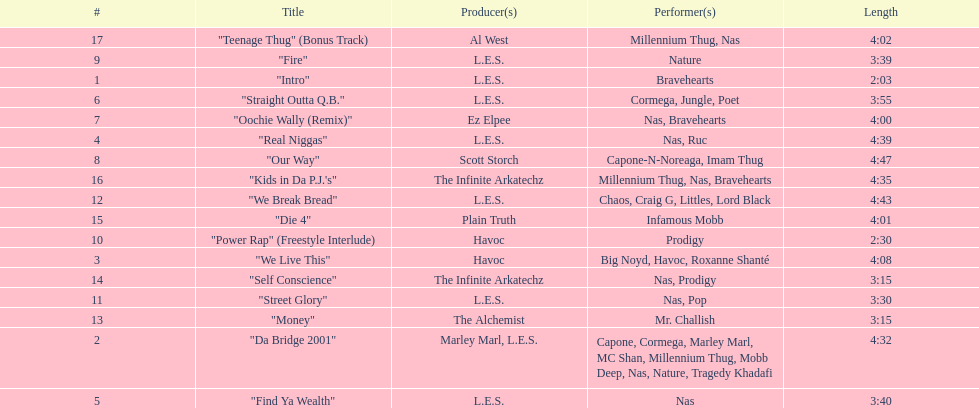How many songs were on the track list? 17. 